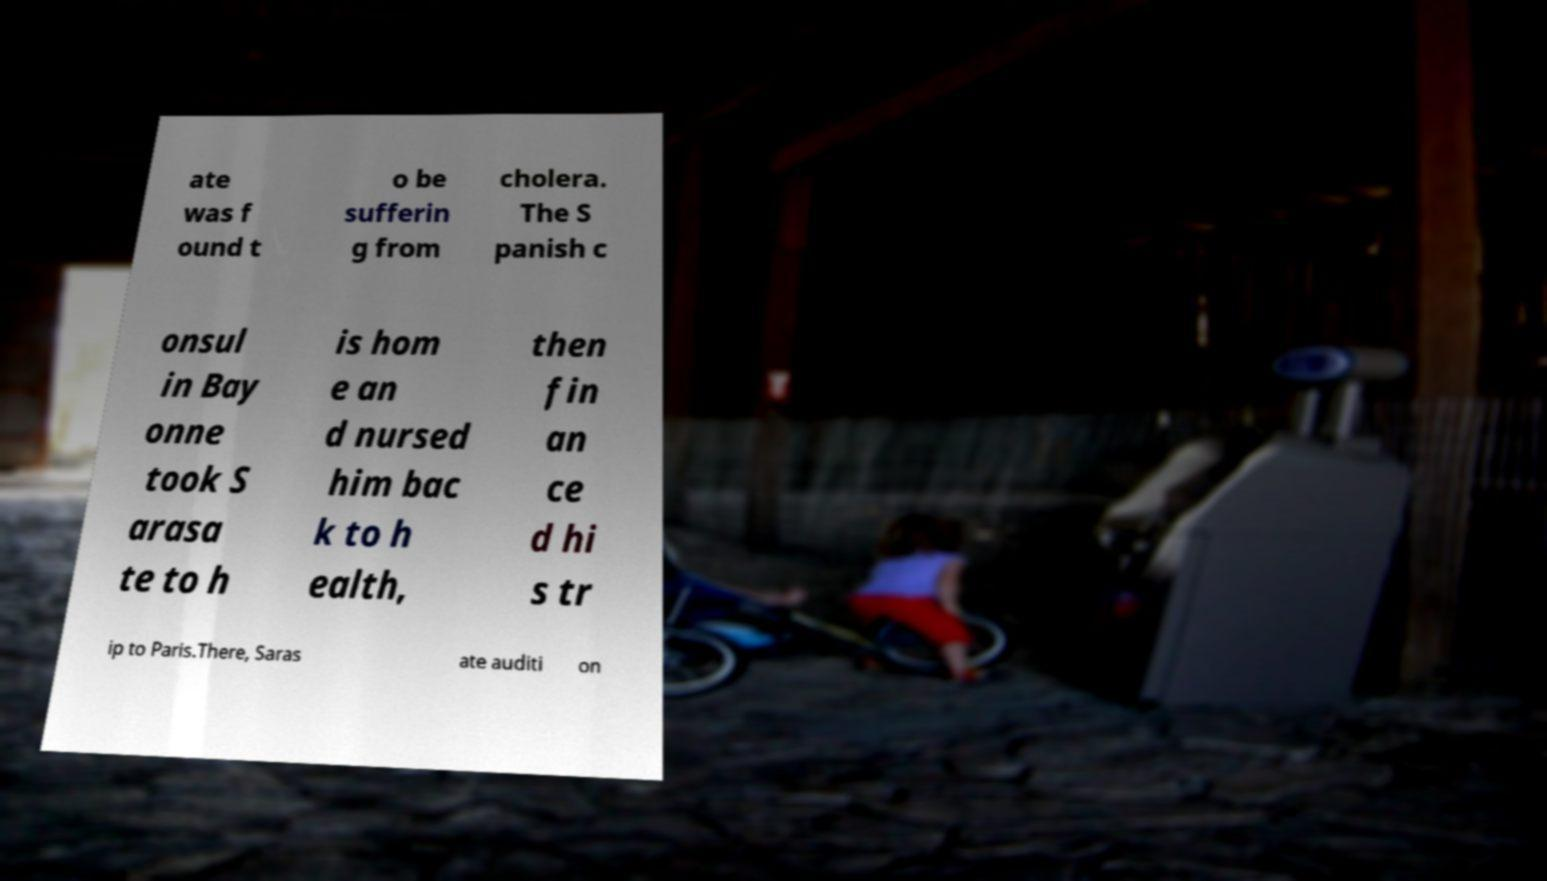Please identify and transcribe the text found in this image. ate was f ound t o be sufferin g from cholera. The S panish c onsul in Bay onne took S arasa te to h is hom e an d nursed him bac k to h ealth, then fin an ce d hi s tr ip to Paris.There, Saras ate auditi on 